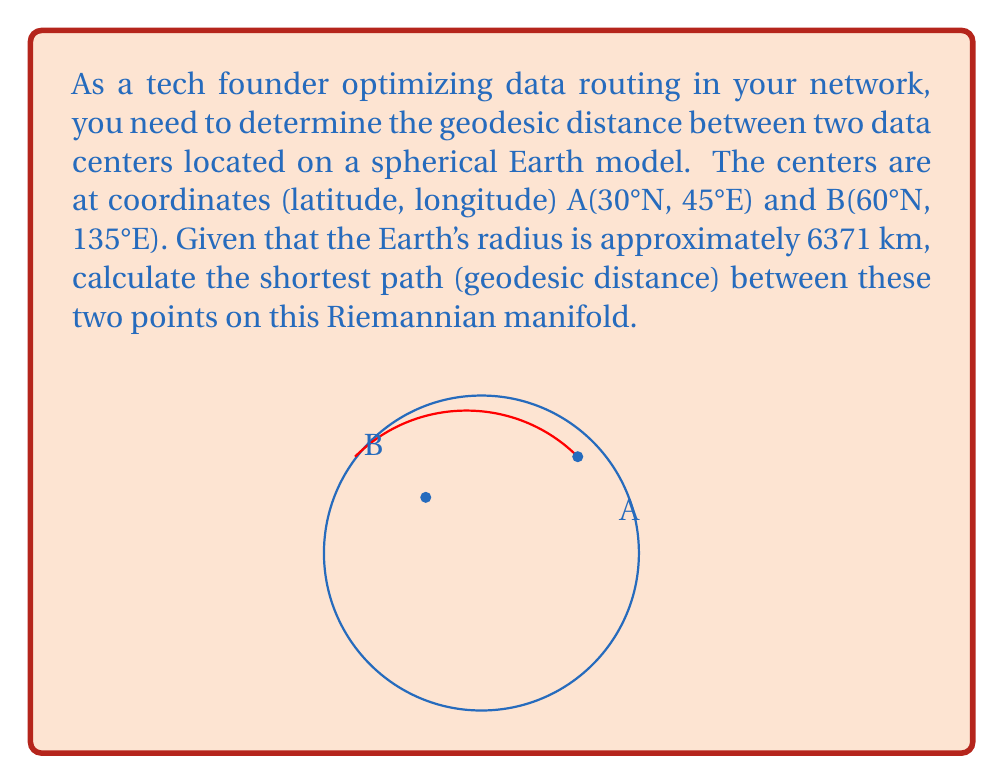Teach me how to tackle this problem. To solve this problem, we'll use the Haversine formula, which is suitable for calculating great-circle distances on a sphere. This approach is relevant to our Riemannian manifold (the Earth's surface) and optimal for data routing applications.

Step 1: Convert latitudes and longitudes to radians.
$$\begin{align}
\phi_1 &= 30° \cdot \frac{\pi}{180} = 0.5236 \text{ rad} \\
\lambda_1 &= 45° \cdot \frac{\pi}{180} = 0.7854 \text{ rad} \\
\phi_2 &= 60° \cdot \frac{\pi}{180} = 1.0472 \text{ rad} \\
\lambda_2 &= 135° \cdot \frac{\pi}{180} = 2.3562 \text{ rad}
\end{align}$$

Step 2: Calculate the differences in latitude and longitude.
$$\begin{align}
\Delta\phi &= \phi_2 - \phi_1 = 0.5236 \text{ rad} \\
\Delta\lambda &= \lambda_2 - \lambda_1 = 1.5708 \text{ rad}
\end{align}$$

Step 3: Apply the Haversine formula.
$$a = \sin^2(\frac{\Delta\phi}{2}) + \cos(\phi_1) \cos(\phi_2) \sin^2(\frac{\Delta\lambda}{2})$$

$$a = \sin^2(0.2618) + \cos(0.5236) \cos(1.0472) \sin^2(0.7854)$$

$$a = 0.2990$$

Step 4: Calculate the central angle.
$$c = 2 \arctan2(\sqrt{a}, \sqrt{1-a}) = 1.1634 \text{ rad}$$

Step 5: Compute the geodesic distance.
$$d = R \cdot c$$
Where $R$ is the Earth's radius (6371 km).

$$d = 6371 \cdot 1.1634 = 7412.0 \text{ km}$$

This geodesic distance represents the optimal path for data routing between the two points on our spherical Riemannian manifold.
Answer: 7412.0 km 